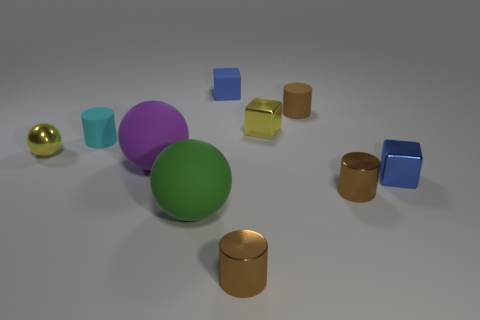Are there any patterns or symmetry in how the objects are arranged? The arrangement of objects seems random without clear patterns or symmetry. The objects are scattered in a way that looks unintentional, with varying distances between them, contributing to a visually balanced but asymmetrical composition. 